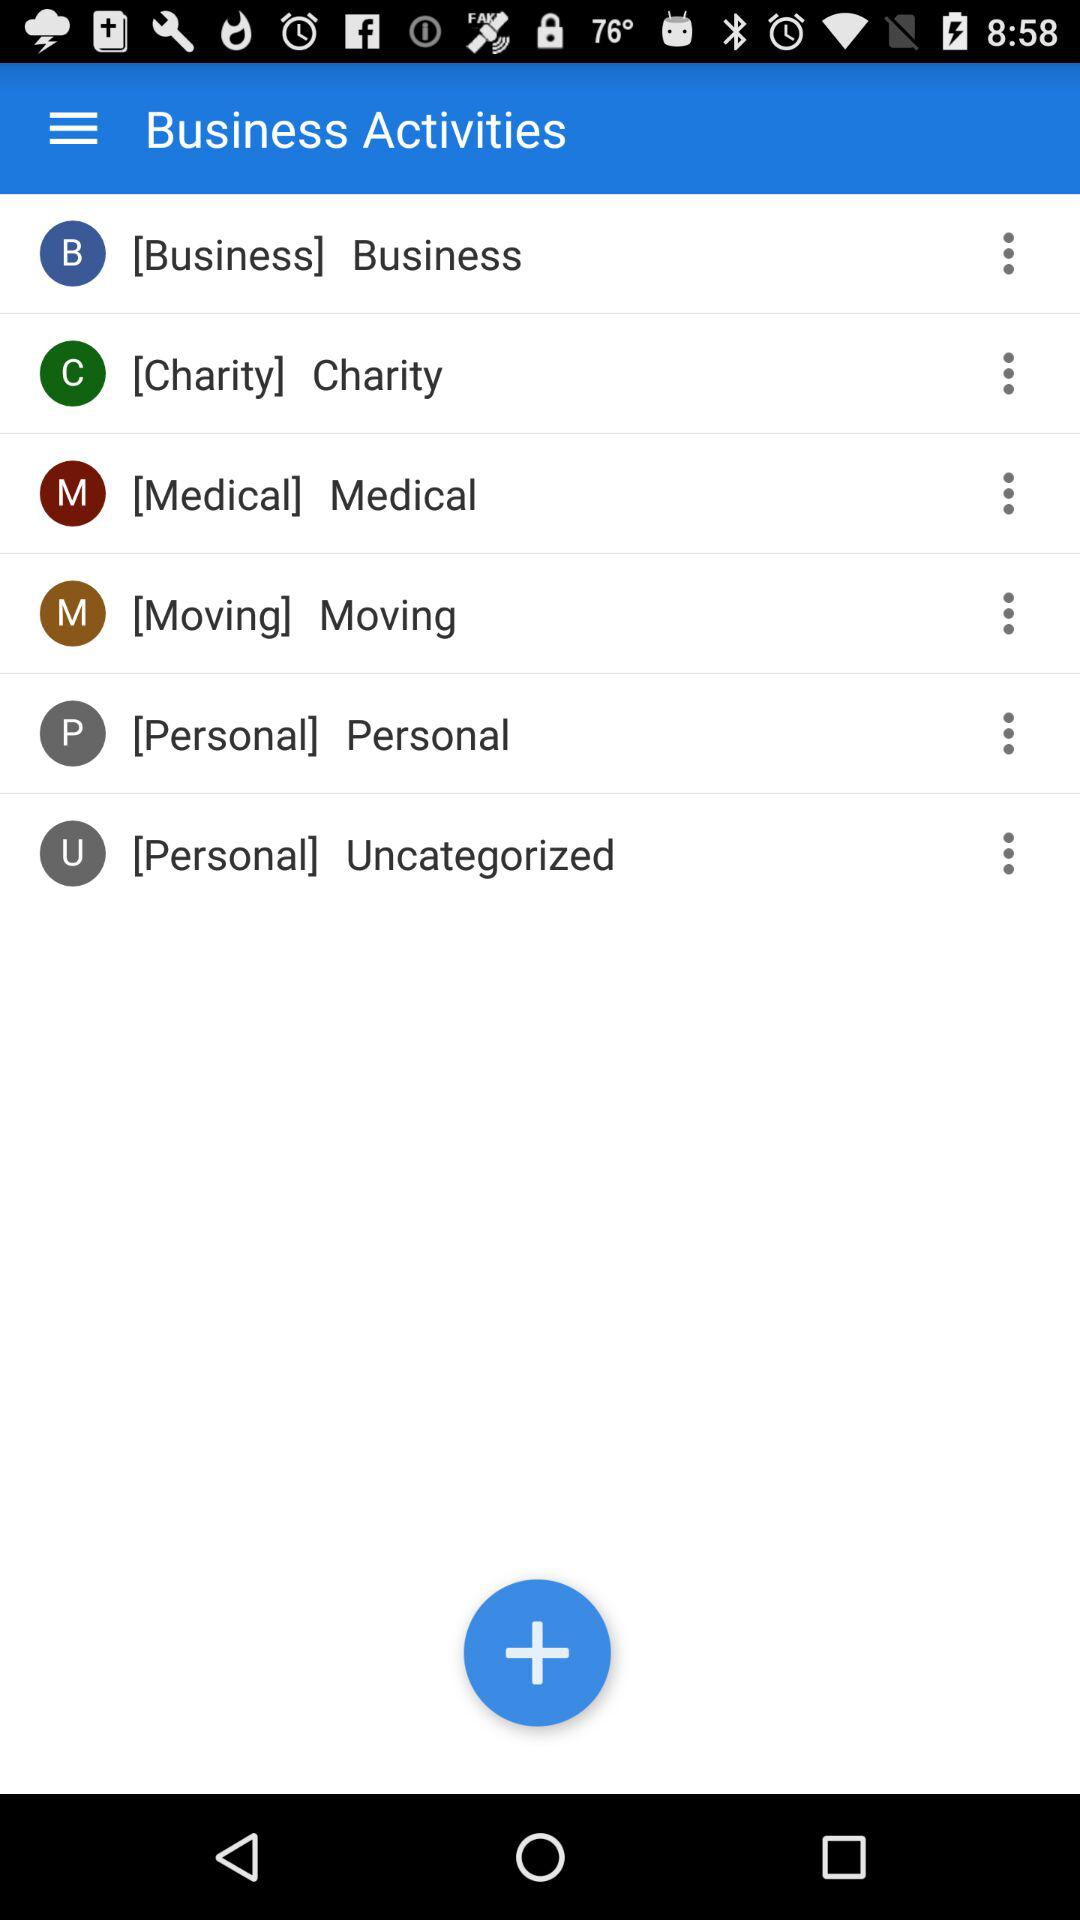How many categories are there in total?
Answer the question using a single word or phrase. 6 